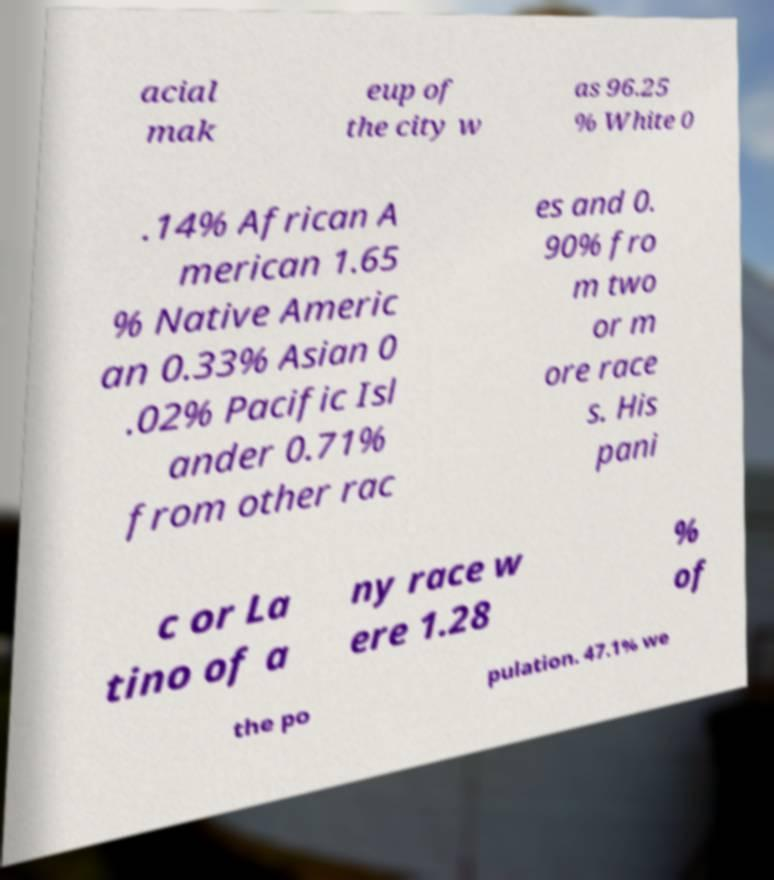There's text embedded in this image that I need extracted. Can you transcribe it verbatim? acial mak eup of the city w as 96.25 % White 0 .14% African A merican 1.65 % Native Americ an 0.33% Asian 0 .02% Pacific Isl ander 0.71% from other rac es and 0. 90% fro m two or m ore race s. His pani c or La tino of a ny race w ere 1.28 % of the po pulation. 47.1% we 